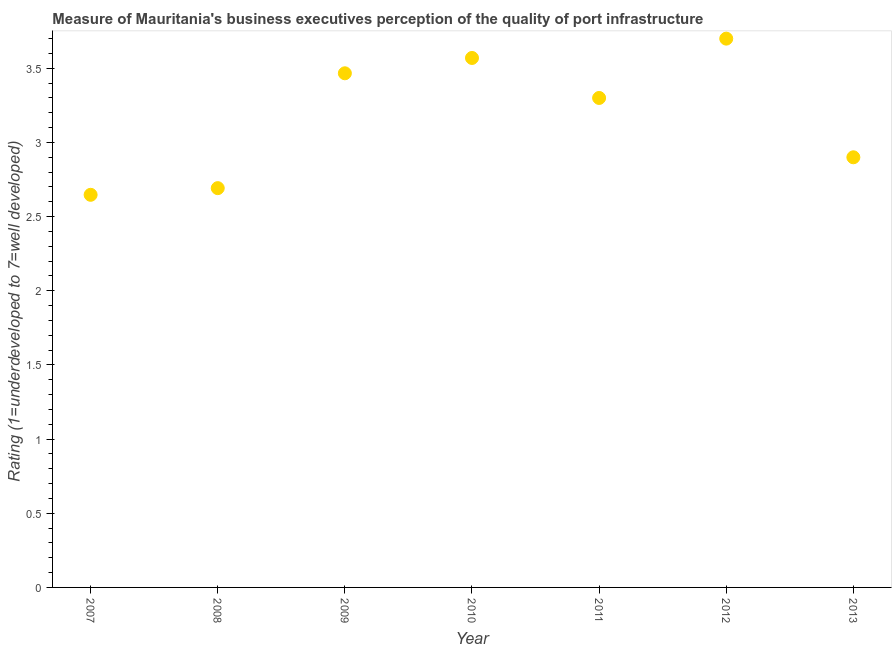What is the rating measuring quality of port infrastructure in 2007?
Provide a succinct answer. 2.65. Across all years, what is the minimum rating measuring quality of port infrastructure?
Ensure brevity in your answer.  2.65. In which year was the rating measuring quality of port infrastructure maximum?
Offer a very short reply. 2012. What is the sum of the rating measuring quality of port infrastructure?
Your response must be concise. 22.28. What is the difference between the rating measuring quality of port infrastructure in 2008 and 2009?
Make the answer very short. -0.77. What is the average rating measuring quality of port infrastructure per year?
Your answer should be very brief. 3.18. Do a majority of the years between 2013 and 2010 (inclusive) have rating measuring quality of port infrastructure greater than 0.30000000000000004 ?
Your answer should be very brief. Yes. What is the ratio of the rating measuring quality of port infrastructure in 2009 to that in 2010?
Ensure brevity in your answer.  0.97. Is the rating measuring quality of port infrastructure in 2007 less than that in 2012?
Offer a terse response. Yes. Is the difference between the rating measuring quality of port infrastructure in 2008 and 2012 greater than the difference between any two years?
Ensure brevity in your answer.  No. What is the difference between the highest and the second highest rating measuring quality of port infrastructure?
Your answer should be compact. 0.13. What is the difference between the highest and the lowest rating measuring quality of port infrastructure?
Give a very brief answer. 1.05. In how many years, is the rating measuring quality of port infrastructure greater than the average rating measuring quality of port infrastructure taken over all years?
Offer a very short reply. 4. Are the values on the major ticks of Y-axis written in scientific E-notation?
Your answer should be compact. No. Does the graph contain grids?
Provide a short and direct response. No. What is the title of the graph?
Your response must be concise. Measure of Mauritania's business executives perception of the quality of port infrastructure. What is the label or title of the Y-axis?
Offer a terse response. Rating (1=underdeveloped to 7=well developed) . What is the Rating (1=underdeveloped to 7=well developed)  in 2007?
Ensure brevity in your answer.  2.65. What is the Rating (1=underdeveloped to 7=well developed)  in 2008?
Your answer should be compact. 2.69. What is the Rating (1=underdeveloped to 7=well developed)  in 2009?
Give a very brief answer. 3.47. What is the Rating (1=underdeveloped to 7=well developed)  in 2010?
Your response must be concise. 3.57. What is the Rating (1=underdeveloped to 7=well developed)  in 2011?
Your answer should be compact. 3.3. What is the Rating (1=underdeveloped to 7=well developed)  in 2012?
Provide a short and direct response. 3.7. What is the difference between the Rating (1=underdeveloped to 7=well developed)  in 2007 and 2008?
Your answer should be compact. -0.04. What is the difference between the Rating (1=underdeveloped to 7=well developed)  in 2007 and 2009?
Your answer should be very brief. -0.82. What is the difference between the Rating (1=underdeveloped to 7=well developed)  in 2007 and 2010?
Your answer should be compact. -0.92. What is the difference between the Rating (1=underdeveloped to 7=well developed)  in 2007 and 2011?
Keep it short and to the point. -0.65. What is the difference between the Rating (1=underdeveloped to 7=well developed)  in 2007 and 2012?
Offer a terse response. -1.05. What is the difference between the Rating (1=underdeveloped to 7=well developed)  in 2007 and 2013?
Your response must be concise. -0.25. What is the difference between the Rating (1=underdeveloped to 7=well developed)  in 2008 and 2009?
Make the answer very short. -0.77. What is the difference between the Rating (1=underdeveloped to 7=well developed)  in 2008 and 2010?
Provide a short and direct response. -0.88. What is the difference between the Rating (1=underdeveloped to 7=well developed)  in 2008 and 2011?
Your answer should be compact. -0.61. What is the difference between the Rating (1=underdeveloped to 7=well developed)  in 2008 and 2012?
Provide a short and direct response. -1.01. What is the difference between the Rating (1=underdeveloped to 7=well developed)  in 2008 and 2013?
Make the answer very short. -0.21. What is the difference between the Rating (1=underdeveloped to 7=well developed)  in 2009 and 2010?
Your answer should be compact. -0.1. What is the difference between the Rating (1=underdeveloped to 7=well developed)  in 2009 and 2011?
Your answer should be very brief. 0.17. What is the difference between the Rating (1=underdeveloped to 7=well developed)  in 2009 and 2012?
Your answer should be very brief. -0.23. What is the difference between the Rating (1=underdeveloped to 7=well developed)  in 2009 and 2013?
Make the answer very short. 0.57. What is the difference between the Rating (1=underdeveloped to 7=well developed)  in 2010 and 2011?
Offer a terse response. 0.27. What is the difference between the Rating (1=underdeveloped to 7=well developed)  in 2010 and 2012?
Keep it short and to the point. -0.13. What is the difference between the Rating (1=underdeveloped to 7=well developed)  in 2010 and 2013?
Ensure brevity in your answer.  0.67. What is the difference between the Rating (1=underdeveloped to 7=well developed)  in 2012 and 2013?
Provide a short and direct response. 0.8. What is the ratio of the Rating (1=underdeveloped to 7=well developed)  in 2007 to that in 2009?
Make the answer very short. 0.76. What is the ratio of the Rating (1=underdeveloped to 7=well developed)  in 2007 to that in 2010?
Offer a very short reply. 0.74. What is the ratio of the Rating (1=underdeveloped to 7=well developed)  in 2007 to that in 2011?
Your response must be concise. 0.8. What is the ratio of the Rating (1=underdeveloped to 7=well developed)  in 2007 to that in 2012?
Ensure brevity in your answer.  0.71. What is the ratio of the Rating (1=underdeveloped to 7=well developed)  in 2008 to that in 2009?
Offer a very short reply. 0.78. What is the ratio of the Rating (1=underdeveloped to 7=well developed)  in 2008 to that in 2010?
Offer a terse response. 0.75. What is the ratio of the Rating (1=underdeveloped to 7=well developed)  in 2008 to that in 2011?
Offer a terse response. 0.82. What is the ratio of the Rating (1=underdeveloped to 7=well developed)  in 2008 to that in 2012?
Your answer should be very brief. 0.73. What is the ratio of the Rating (1=underdeveloped to 7=well developed)  in 2008 to that in 2013?
Your answer should be compact. 0.93. What is the ratio of the Rating (1=underdeveloped to 7=well developed)  in 2009 to that in 2010?
Your answer should be compact. 0.97. What is the ratio of the Rating (1=underdeveloped to 7=well developed)  in 2009 to that in 2011?
Provide a succinct answer. 1.05. What is the ratio of the Rating (1=underdeveloped to 7=well developed)  in 2009 to that in 2012?
Your answer should be compact. 0.94. What is the ratio of the Rating (1=underdeveloped to 7=well developed)  in 2009 to that in 2013?
Make the answer very short. 1.2. What is the ratio of the Rating (1=underdeveloped to 7=well developed)  in 2010 to that in 2011?
Make the answer very short. 1.08. What is the ratio of the Rating (1=underdeveloped to 7=well developed)  in 2010 to that in 2012?
Make the answer very short. 0.96. What is the ratio of the Rating (1=underdeveloped to 7=well developed)  in 2010 to that in 2013?
Your response must be concise. 1.23. What is the ratio of the Rating (1=underdeveloped to 7=well developed)  in 2011 to that in 2012?
Offer a terse response. 0.89. What is the ratio of the Rating (1=underdeveloped to 7=well developed)  in 2011 to that in 2013?
Keep it short and to the point. 1.14. What is the ratio of the Rating (1=underdeveloped to 7=well developed)  in 2012 to that in 2013?
Your answer should be compact. 1.28. 